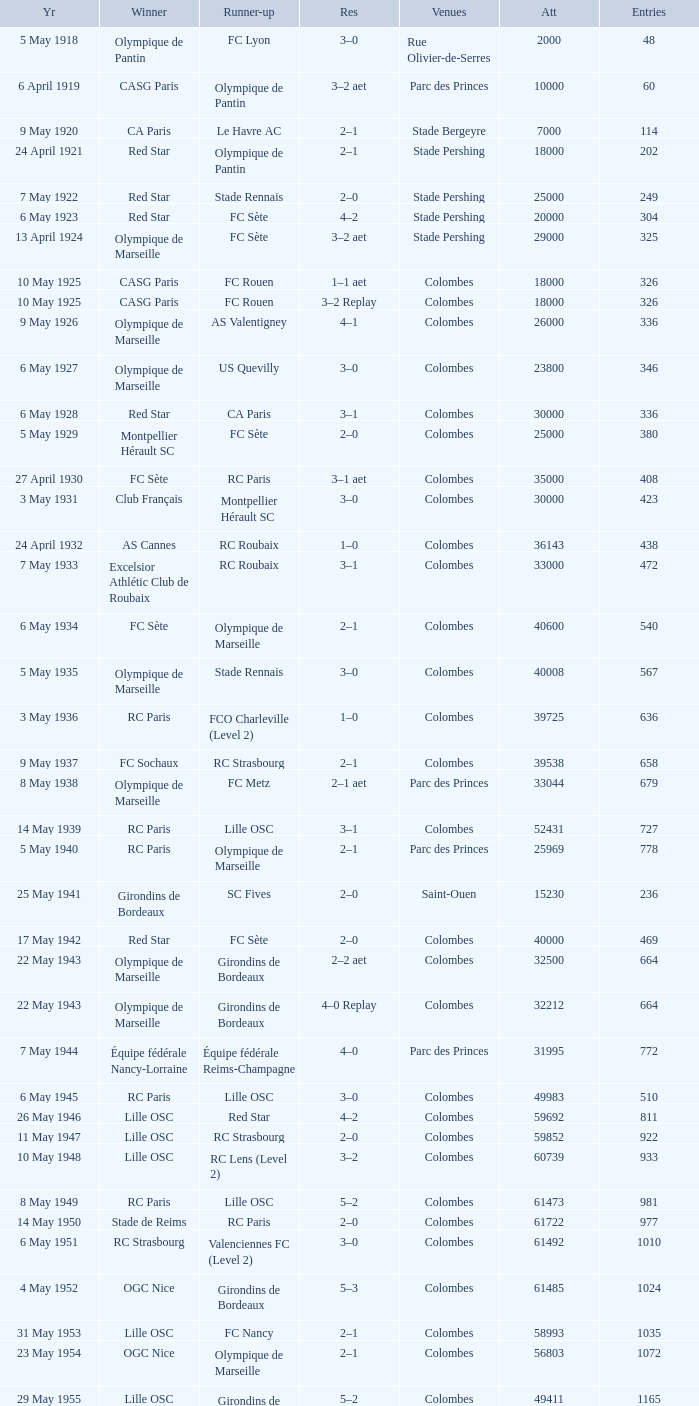How many games had red star as the runner up? 1.0. 